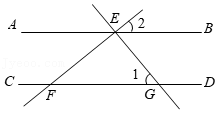Can you explain the significance of the labels 1 and 2 on the diagram? Certainly! The numbers 1 and 2 in the diagram likely refer to specific angles that are of interest. Angle 1 could be illustrating an angle formed by the intersection of line EF with line CD, specifically at point G. Angle 2 represents another angle adjacent to Angle 1, possibly an alternate interior or corresponding angle. These labels suggest that focus is being directed at these particular angles, perhaps for discussing angle congruency or relationships in the context of parallel lines cut by a transversal. 